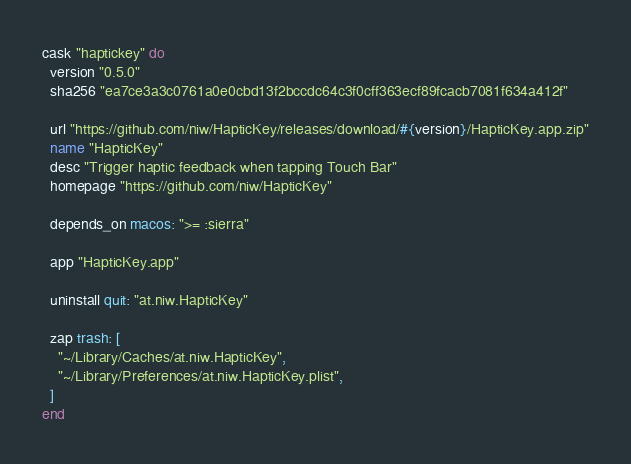<code> <loc_0><loc_0><loc_500><loc_500><_Ruby_>cask "haptickey" do
  version "0.5.0"
  sha256 "ea7ce3a3c0761a0e0cbd13f2bccdc64c3f0cff363ecf89fcacb7081f634a412f"

  url "https://github.com/niw/HapticKey/releases/download/#{version}/HapticKey.app.zip"
  name "HapticKey"
  desc "Trigger haptic feedback when tapping Touch Bar"
  homepage "https://github.com/niw/HapticKey"

  depends_on macos: ">= :sierra"

  app "HapticKey.app"

  uninstall quit: "at.niw.HapticKey"

  zap trash: [
    "~/Library/Caches/at.niw.HapticKey",
    "~/Library/Preferences/at.niw.HapticKey.plist",
  ]
end
</code> 